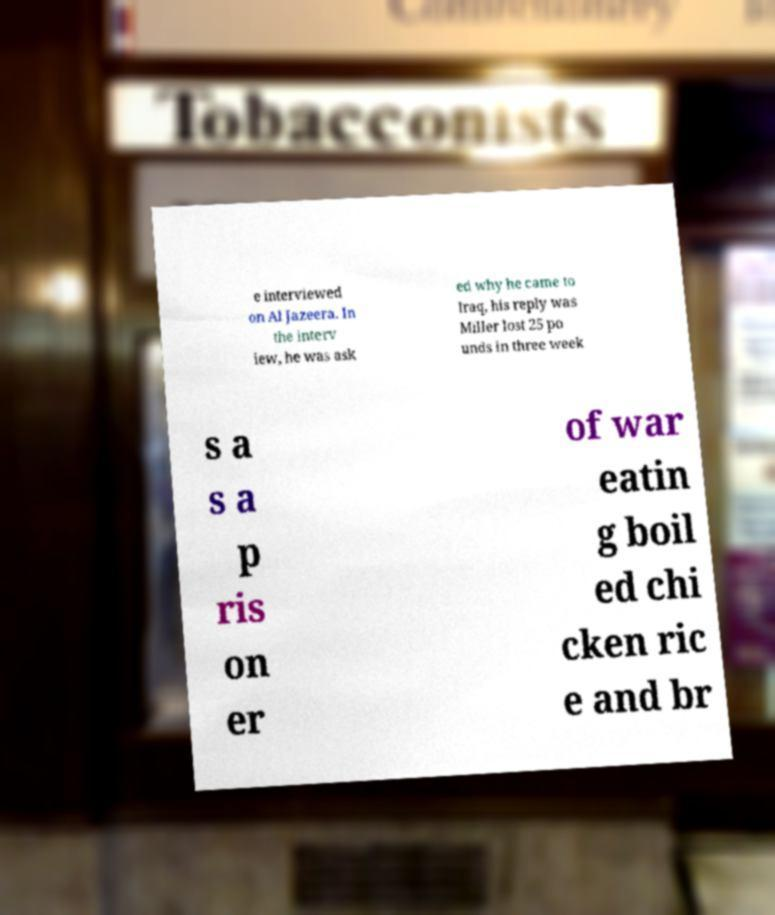Please read and relay the text visible in this image. What does it say? e interviewed on Al Jazeera. In the interv iew, he was ask ed why he came to Iraq, his reply was Miller lost 25 po unds in three week s a s a p ris on er of war eatin g boil ed chi cken ric e and br 